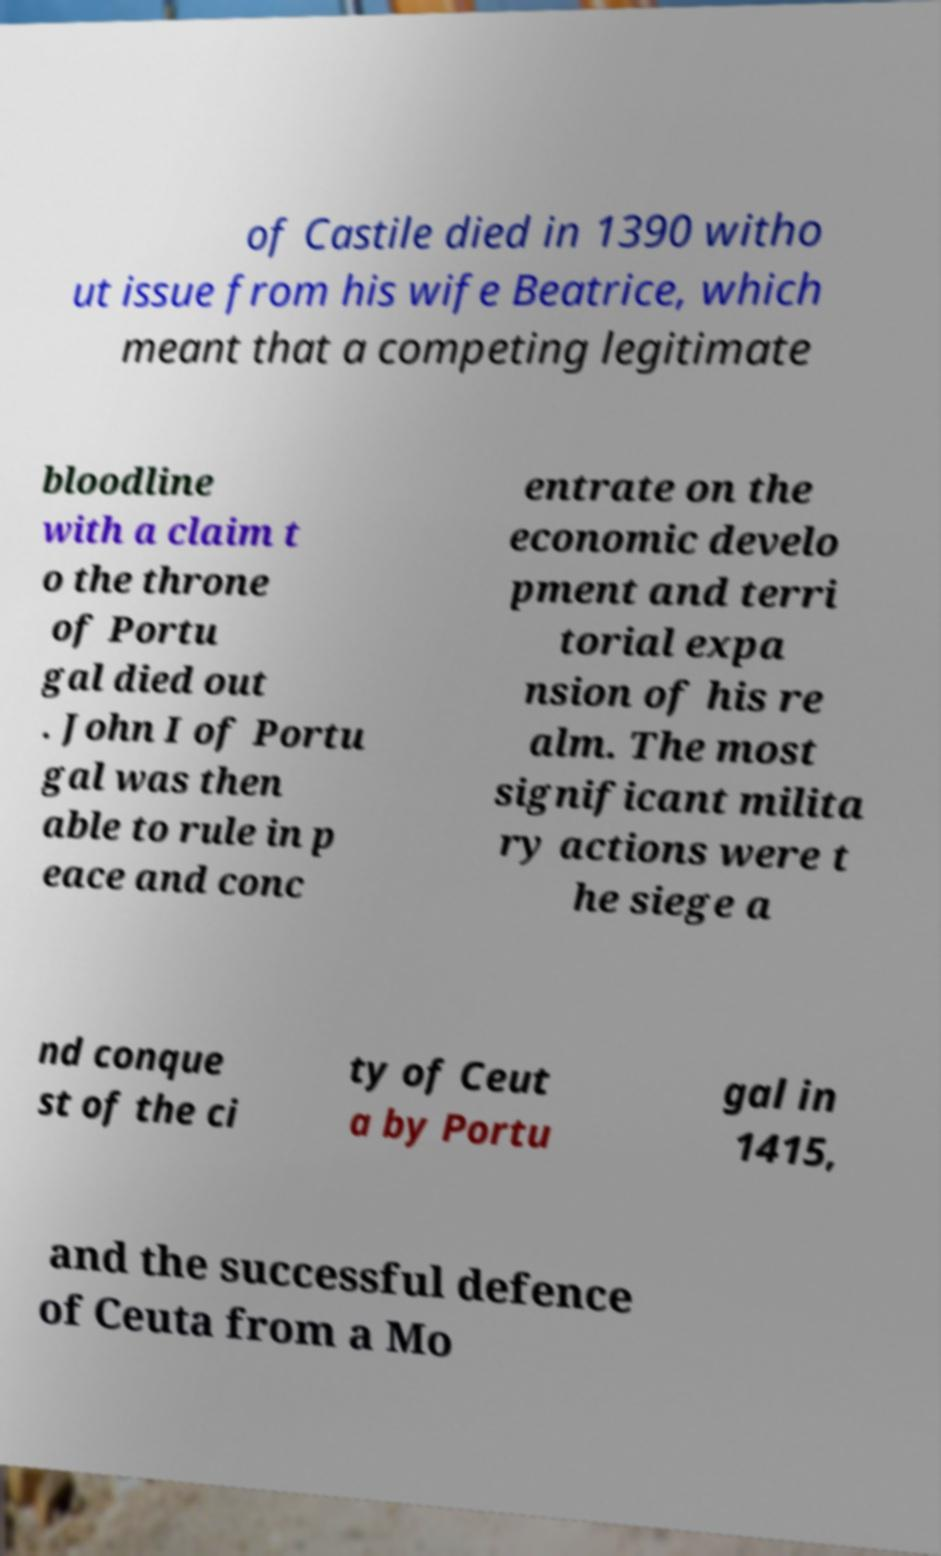Please identify and transcribe the text found in this image. of Castile died in 1390 witho ut issue from his wife Beatrice, which meant that a competing legitimate bloodline with a claim t o the throne of Portu gal died out . John I of Portu gal was then able to rule in p eace and conc entrate on the economic develo pment and terri torial expa nsion of his re alm. The most significant milita ry actions were t he siege a nd conque st of the ci ty of Ceut a by Portu gal in 1415, and the successful defence of Ceuta from a Mo 